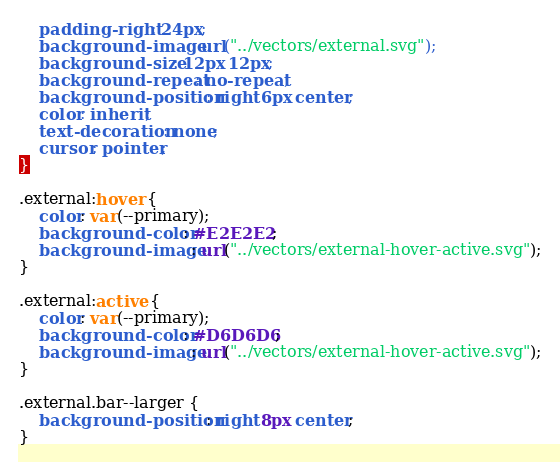Convert code to text. <code><loc_0><loc_0><loc_500><loc_500><_CSS_>    padding-right: 24px;
    background-image: url("../vectors/external.svg");
    background-size: 12px 12px;
    background-repeat: no-repeat;
    background-position: right 6px center;
    color: inherit;
    text-decoration: none;
    cursor: pointer;
}

.external:hover {
    color: var(--primary);
    background-color: #E2E2E2;
    background-image: url("../vectors/external-hover-active.svg");
}

.external:active {
    color: var(--primary);
    background-color: #D6D6D6;
    background-image: url("../vectors/external-hover-active.svg");
}

.external.bar--larger {
    background-position: right 8px center;
}
</code> 